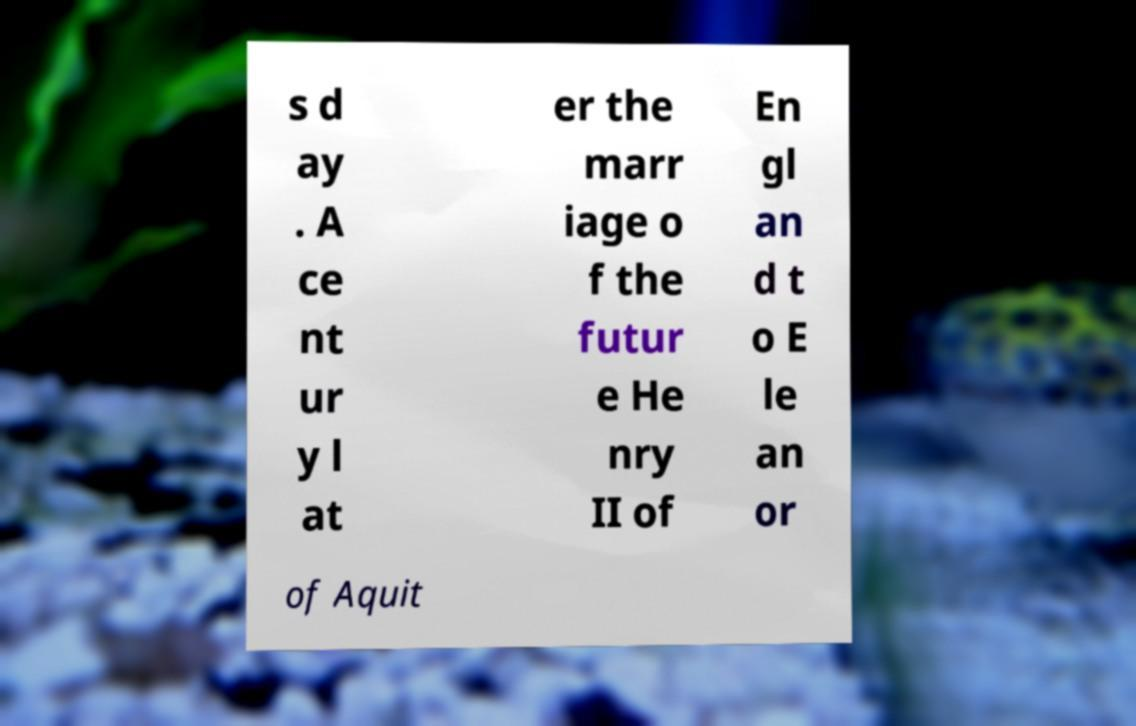Could you assist in decoding the text presented in this image and type it out clearly? s d ay . A ce nt ur y l at er the marr iage o f the futur e He nry II of En gl an d t o E le an or of Aquit 